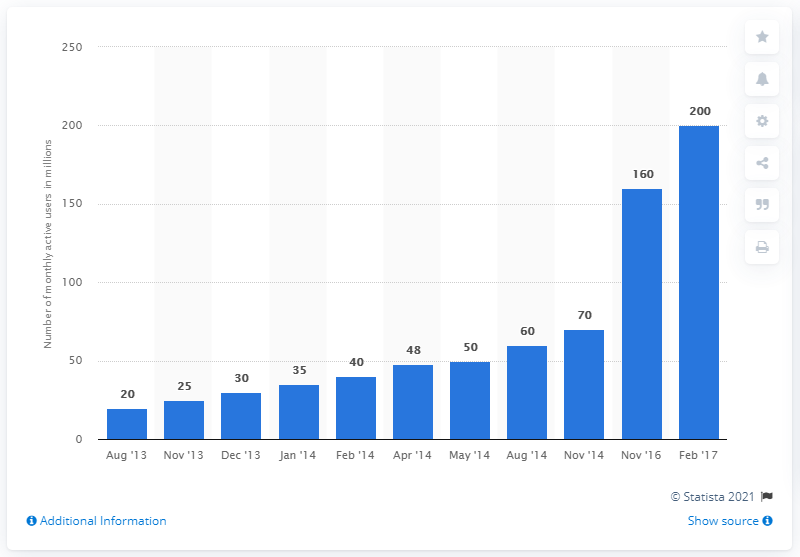Point out several critical features in this image. In February 2017, India had approximately 200,000 monthly active users. 